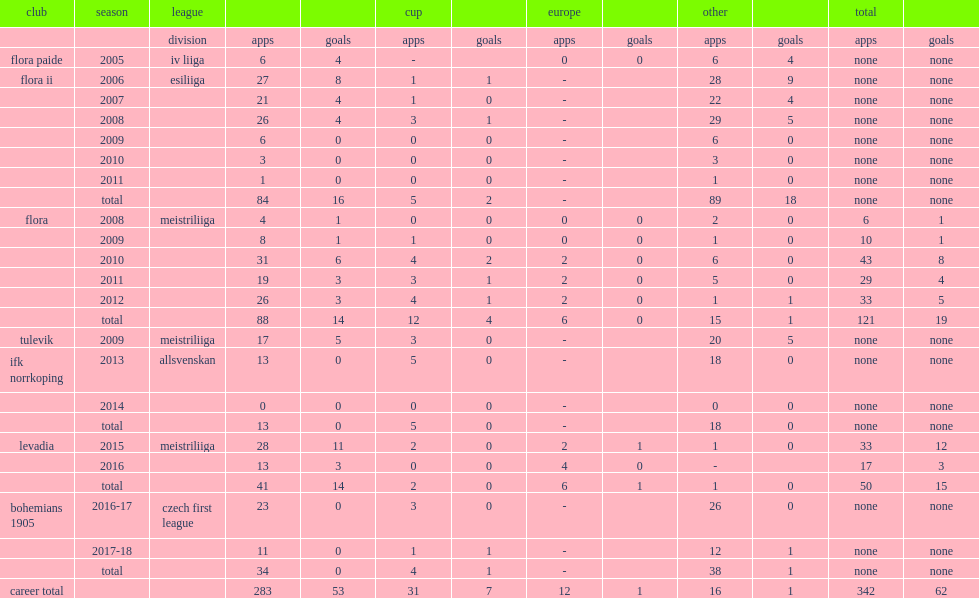How many league goals did luts score for flora in 2010. 6.0. 